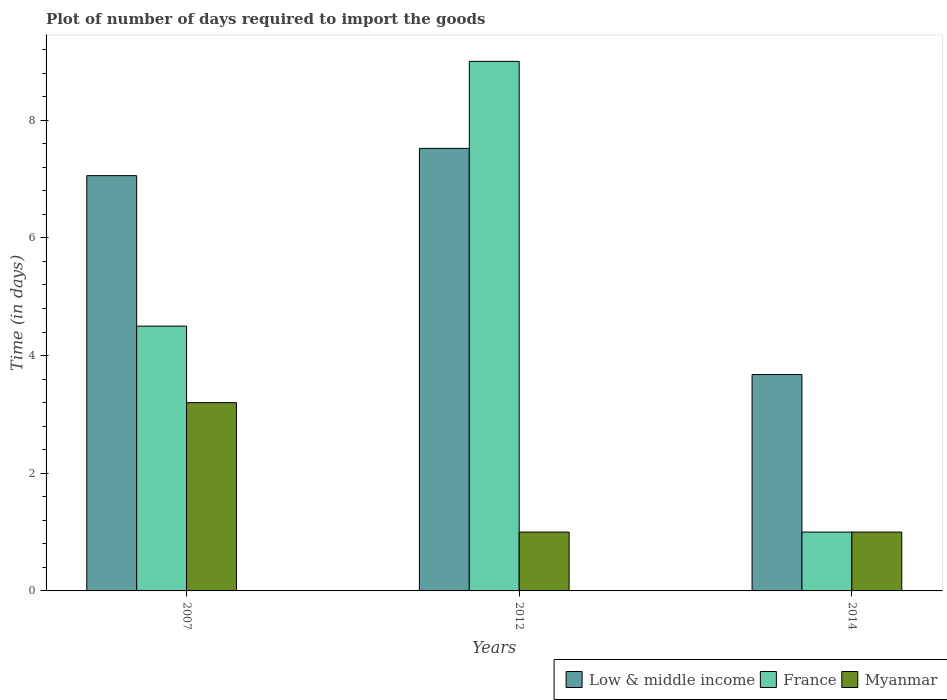How many different coloured bars are there?
Keep it short and to the point. 3. Are the number of bars per tick equal to the number of legend labels?
Offer a very short reply. Yes. How many bars are there on the 1st tick from the left?
Your answer should be compact. 3. What is the time required to import goods in Myanmar in 2012?
Keep it short and to the point. 1. Across all years, what is the minimum time required to import goods in Low & middle income?
Give a very brief answer. 3.68. In which year was the time required to import goods in Myanmar minimum?
Give a very brief answer. 2012. What is the total time required to import goods in Myanmar in the graph?
Make the answer very short. 5.2. What is the difference between the time required to import goods in France in 2012 and that in 2014?
Give a very brief answer. 8. What is the difference between the time required to import goods in Low & middle income in 2014 and the time required to import goods in Myanmar in 2012?
Keep it short and to the point. 2.68. What is the average time required to import goods in Low & middle income per year?
Offer a terse response. 6.09. In the year 2012, what is the difference between the time required to import goods in Myanmar and time required to import goods in France?
Make the answer very short. -8. Is the difference between the time required to import goods in Myanmar in 2007 and 2014 greater than the difference between the time required to import goods in France in 2007 and 2014?
Keep it short and to the point. No. What is the difference between the highest and the lowest time required to import goods in Low & middle income?
Your response must be concise. 3.84. What does the 1st bar from the right in 2012 represents?
Your answer should be very brief. Myanmar. Is it the case that in every year, the sum of the time required to import goods in Myanmar and time required to import goods in Low & middle income is greater than the time required to import goods in France?
Your answer should be very brief. No. How many years are there in the graph?
Provide a succinct answer. 3. Are the values on the major ticks of Y-axis written in scientific E-notation?
Offer a terse response. No. Does the graph contain grids?
Offer a terse response. No. How are the legend labels stacked?
Make the answer very short. Horizontal. What is the title of the graph?
Ensure brevity in your answer.  Plot of number of days required to import the goods. What is the label or title of the X-axis?
Keep it short and to the point. Years. What is the label or title of the Y-axis?
Ensure brevity in your answer.  Time (in days). What is the Time (in days) in Low & middle income in 2007?
Make the answer very short. 7.06. What is the Time (in days) of France in 2007?
Your response must be concise. 4.5. What is the Time (in days) of Myanmar in 2007?
Your answer should be compact. 3.2. What is the Time (in days) in Low & middle income in 2012?
Ensure brevity in your answer.  7.52. What is the Time (in days) in Myanmar in 2012?
Give a very brief answer. 1. What is the Time (in days) of Low & middle income in 2014?
Keep it short and to the point. 3.68. What is the Time (in days) in France in 2014?
Provide a succinct answer. 1. Across all years, what is the maximum Time (in days) in Low & middle income?
Your answer should be compact. 7.52. Across all years, what is the maximum Time (in days) in France?
Your answer should be compact. 9. Across all years, what is the maximum Time (in days) of Myanmar?
Provide a succinct answer. 3.2. Across all years, what is the minimum Time (in days) of Low & middle income?
Provide a succinct answer. 3.68. What is the total Time (in days) in Low & middle income in the graph?
Your answer should be compact. 18.26. What is the difference between the Time (in days) in Low & middle income in 2007 and that in 2012?
Offer a very short reply. -0.46. What is the difference between the Time (in days) in France in 2007 and that in 2012?
Your answer should be compact. -4.5. What is the difference between the Time (in days) in Low & middle income in 2007 and that in 2014?
Your response must be concise. 3.38. What is the difference between the Time (in days) in Low & middle income in 2012 and that in 2014?
Provide a succinct answer. 3.84. What is the difference between the Time (in days) of Myanmar in 2012 and that in 2014?
Your answer should be very brief. 0. What is the difference between the Time (in days) in Low & middle income in 2007 and the Time (in days) in France in 2012?
Offer a terse response. -1.94. What is the difference between the Time (in days) of Low & middle income in 2007 and the Time (in days) of Myanmar in 2012?
Make the answer very short. 6.06. What is the difference between the Time (in days) in France in 2007 and the Time (in days) in Myanmar in 2012?
Offer a very short reply. 3.5. What is the difference between the Time (in days) of Low & middle income in 2007 and the Time (in days) of France in 2014?
Provide a short and direct response. 6.06. What is the difference between the Time (in days) of Low & middle income in 2007 and the Time (in days) of Myanmar in 2014?
Give a very brief answer. 6.06. What is the difference between the Time (in days) of France in 2007 and the Time (in days) of Myanmar in 2014?
Ensure brevity in your answer.  3.5. What is the difference between the Time (in days) of Low & middle income in 2012 and the Time (in days) of France in 2014?
Provide a short and direct response. 6.52. What is the difference between the Time (in days) in Low & middle income in 2012 and the Time (in days) in Myanmar in 2014?
Provide a short and direct response. 6.52. What is the difference between the Time (in days) of France in 2012 and the Time (in days) of Myanmar in 2014?
Make the answer very short. 8. What is the average Time (in days) in Low & middle income per year?
Your answer should be compact. 6.09. What is the average Time (in days) in France per year?
Your answer should be compact. 4.83. What is the average Time (in days) in Myanmar per year?
Your answer should be very brief. 1.73. In the year 2007, what is the difference between the Time (in days) of Low & middle income and Time (in days) of France?
Give a very brief answer. 2.56. In the year 2007, what is the difference between the Time (in days) in Low & middle income and Time (in days) in Myanmar?
Give a very brief answer. 3.86. In the year 2007, what is the difference between the Time (in days) in France and Time (in days) in Myanmar?
Keep it short and to the point. 1.3. In the year 2012, what is the difference between the Time (in days) in Low & middle income and Time (in days) in France?
Your answer should be very brief. -1.48. In the year 2012, what is the difference between the Time (in days) in Low & middle income and Time (in days) in Myanmar?
Your answer should be very brief. 6.52. In the year 2012, what is the difference between the Time (in days) in France and Time (in days) in Myanmar?
Offer a terse response. 8. In the year 2014, what is the difference between the Time (in days) in Low & middle income and Time (in days) in France?
Your answer should be compact. 2.68. In the year 2014, what is the difference between the Time (in days) in Low & middle income and Time (in days) in Myanmar?
Offer a terse response. 2.68. In the year 2014, what is the difference between the Time (in days) in France and Time (in days) in Myanmar?
Ensure brevity in your answer.  0. What is the ratio of the Time (in days) in Low & middle income in 2007 to that in 2012?
Make the answer very short. 0.94. What is the ratio of the Time (in days) in France in 2007 to that in 2012?
Keep it short and to the point. 0.5. What is the ratio of the Time (in days) of Myanmar in 2007 to that in 2012?
Your answer should be compact. 3.2. What is the ratio of the Time (in days) of Low & middle income in 2007 to that in 2014?
Your answer should be very brief. 1.92. What is the ratio of the Time (in days) in Low & middle income in 2012 to that in 2014?
Offer a terse response. 2.05. What is the difference between the highest and the second highest Time (in days) of Low & middle income?
Ensure brevity in your answer.  0.46. What is the difference between the highest and the second highest Time (in days) of France?
Your answer should be very brief. 4.5. What is the difference between the highest and the lowest Time (in days) in Low & middle income?
Your answer should be compact. 3.84. What is the difference between the highest and the lowest Time (in days) of France?
Make the answer very short. 8. 